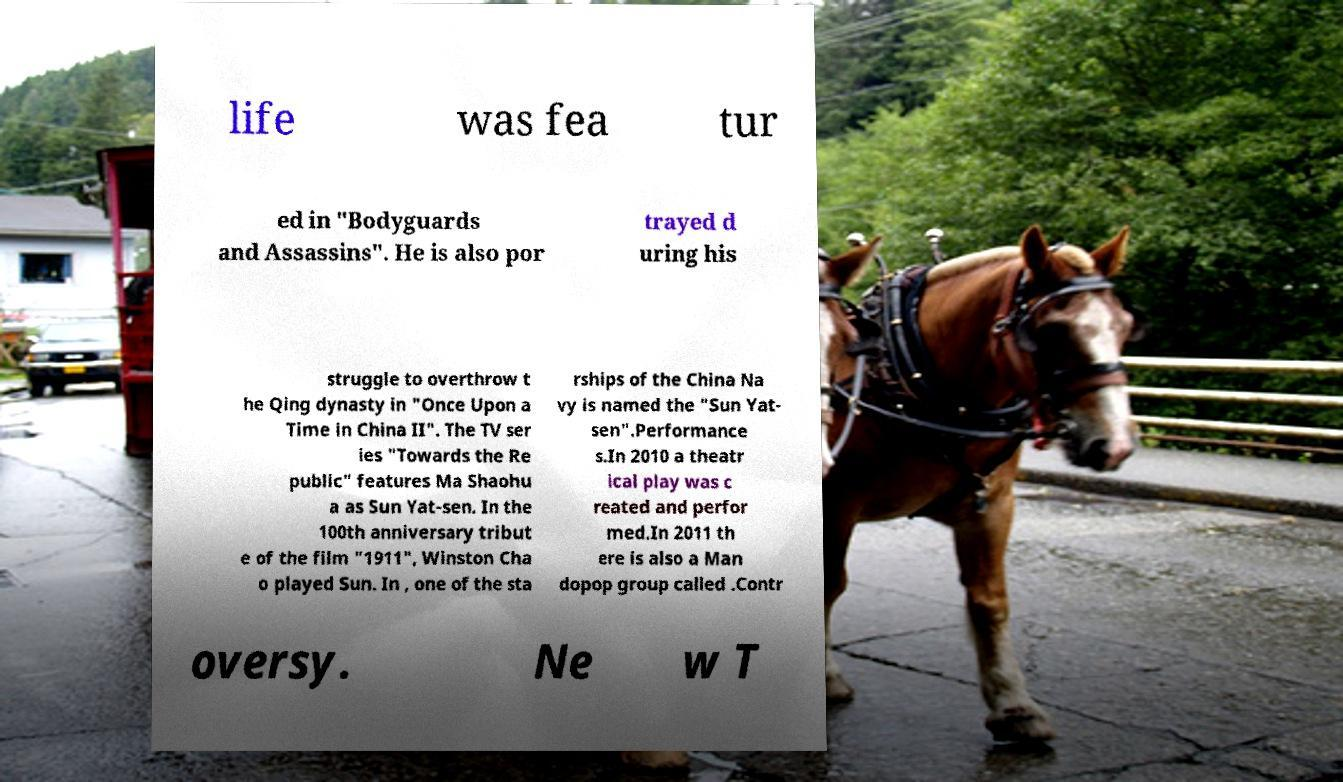There's text embedded in this image that I need extracted. Can you transcribe it verbatim? life was fea tur ed in "Bodyguards and Assassins". He is also por trayed d uring his struggle to overthrow t he Qing dynasty in "Once Upon a Time in China II". The TV ser ies "Towards the Re public" features Ma Shaohu a as Sun Yat-sen. In the 100th anniversary tribut e of the film "1911", Winston Cha o played Sun. In , one of the sta rships of the China Na vy is named the "Sun Yat- sen".Performance s.In 2010 a theatr ical play was c reated and perfor med.In 2011 th ere is also a Man dopop group called .Contr oversy. Ne w T 